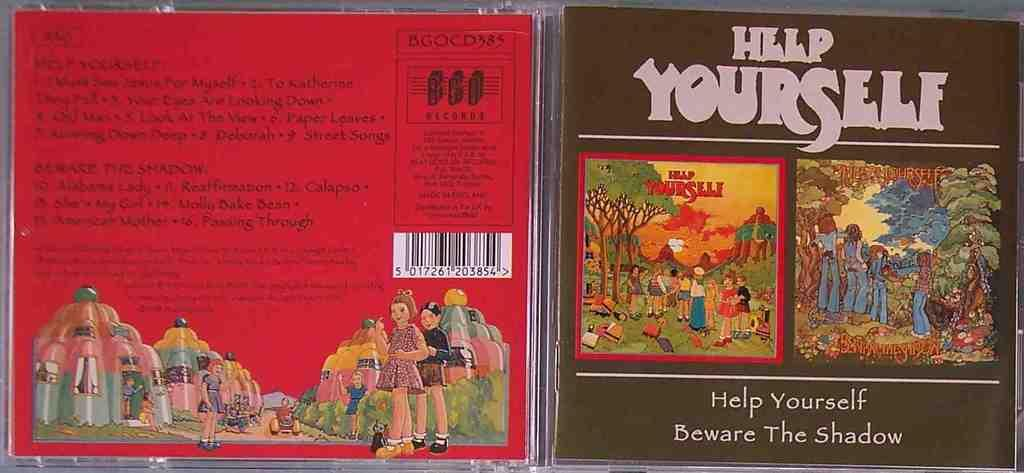<image>
Give a short and clear explanation of the subsequent image. Two CD or DVD cases are titled Help Yourself; Beware the Shadow. 